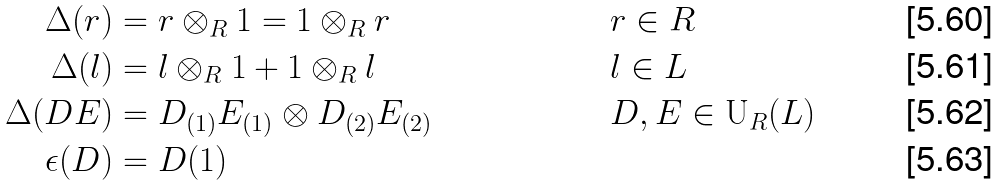Convert formula to latex. <formula><loc_0><loc_0><loc_500><loc_500>\Delta ( r ) & = r \otimes _ { R } 1 = 1 \otimes _ { R } r & & r \in R \\ \Delta ( l ) & = l \otimes _ { R } 1 + 1 \otimes _ { R } l & & l \in L \\ \Delta ( D E ) & = D _ { ( 1 ) } E _ { ( 1 ) } \otimes D _ { ( 2 ) } E _ { ( 2 ) } & & D , E \in \mathrm U _ { R } ( L ) \\ \epsilon ( D ) & = D ( 1 )</formula> 